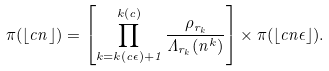Convert formula to latex. <formula><loc_0><loc_0><loc_500><loc_500>\pi ( \lfloor c n \rfloor ) = \left [ \prod _ { k = k ( c \epsilon ) + 1 } ^ { k ( c ) } \frac { \rho _ { r _ { k } } } { \Lambda _ { r _ { k } } ( n ^ { k } ) } \right ] \times \pi ( \lfloor c n \epsilon \rfloor ) .</formula> 